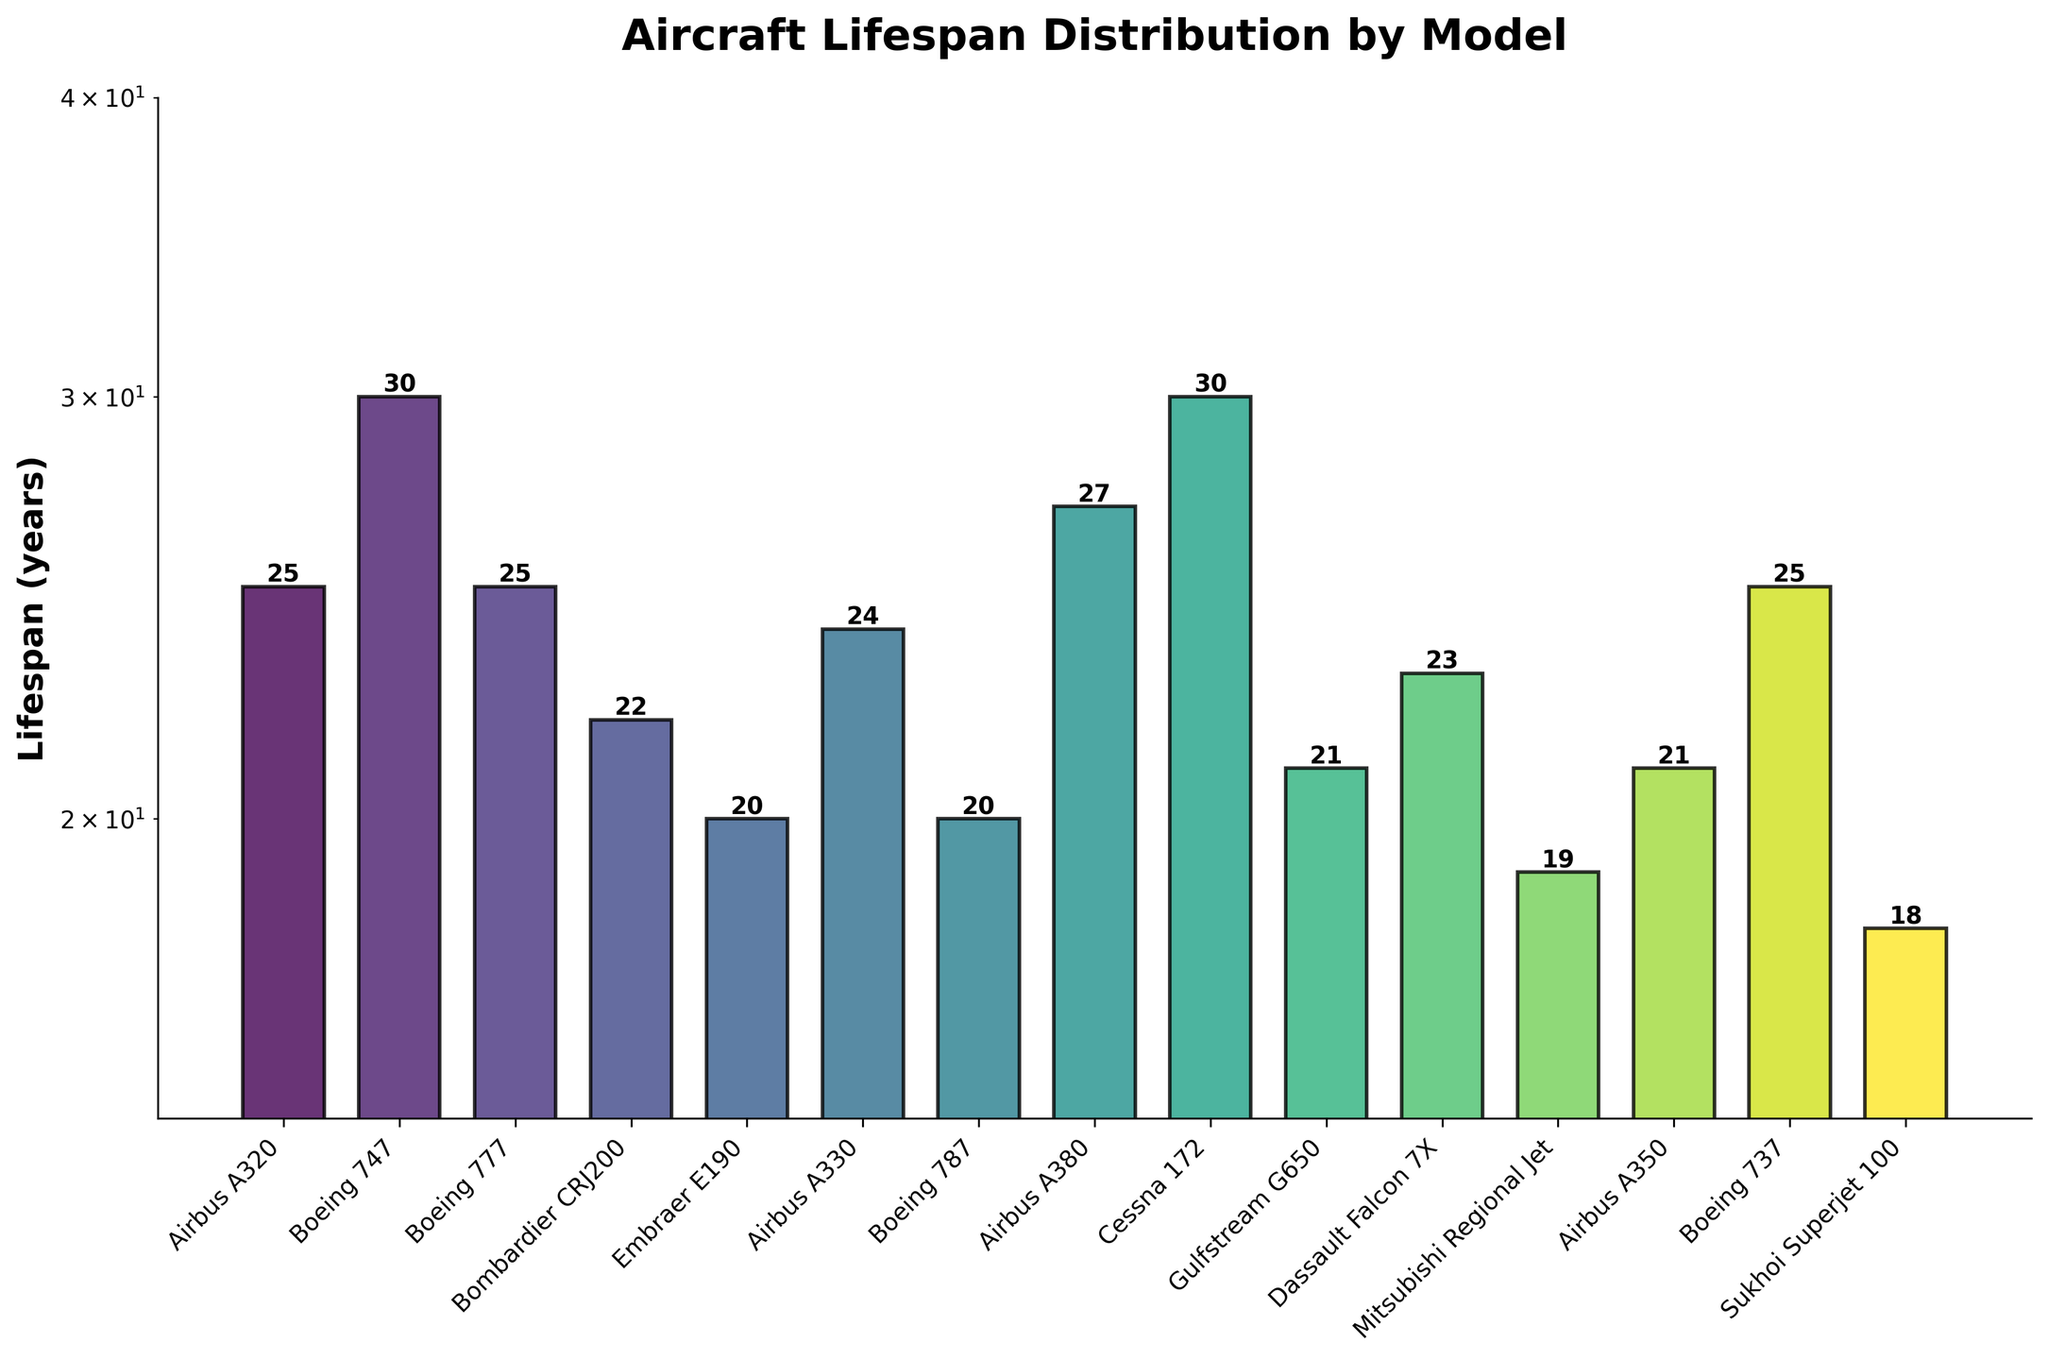How many aircraft models have a lifespan of 25 years? We count the bars corresponding to the models that have a height at the "25" mark on the y-axis.
Answer: 3 What is the title of the plot? The title is usually placed at the top of the plot and represents the main information the plot is about. In this case, the title is clear.
Answer: Aircraft Lifespan Distribution by Model Which aircraft model has the shortest lifespan, and what is it? First, identify the shortest bar in the plot, then read the corresponding model label on the x-axis and the lifespan value on the y-axis.
Answer: Sukhoi Superjet 100, 18 What is the lifespan difference between the Boeing 787 and the Airbus A380? Identify the heights of the bars corresponding to Boeing 787 and Airbus A380, then subtract the smaller value from the bigger value: 27 (Airbus A380) - 20 (Boeing 787) = 7.
Answer: 7 years Which aircraft models have the same lifespan of 30 years? Identify the bars that reach the 30-year mark on the y-axis and read their corresponding labels on the x-axis.
Answer: Boeing 747, Cessna 172 What is the median lifespan of all aircraft models? List all lifespans in ascending order and find the middle value(s). Since there are 15 data points, the median is the 8th value from the ordered list. The sorted lifespans are [18, 19, 20, 20, 21, 21, 22, 23, 24, 25, 25, 25, 27, 30, 30]. The 8th value is 23.
Answer: 23 years Which aircraft model has the highest lifespan, and what is it? Identify the highest bar in the plot, then read the corresponding model label on the x-axis and the lifespan value on the y-axis.
Answer: Boeing 747 and Cessna 172, 30 What percentage of the aircraft models have a lifespan of 20 years or less? Count the number of aircraft with a lifespan of 20 years or less, divide by the total number of aircraft models (15), and multiply by 100: (5 / 15) * 100 = 33.3%.
Answer: 33.3% What is the average lifespan of the aircraft models with a lifespan over 25 years? Identify the models with lifespans greater than 25 (Airbus A380 (27), Boeing 747 (30), and Cessna 172 (30)), sum their lifespans and divide by their count: (27 + 30 + 30) / 3 = 29.
Answer: 29 years 